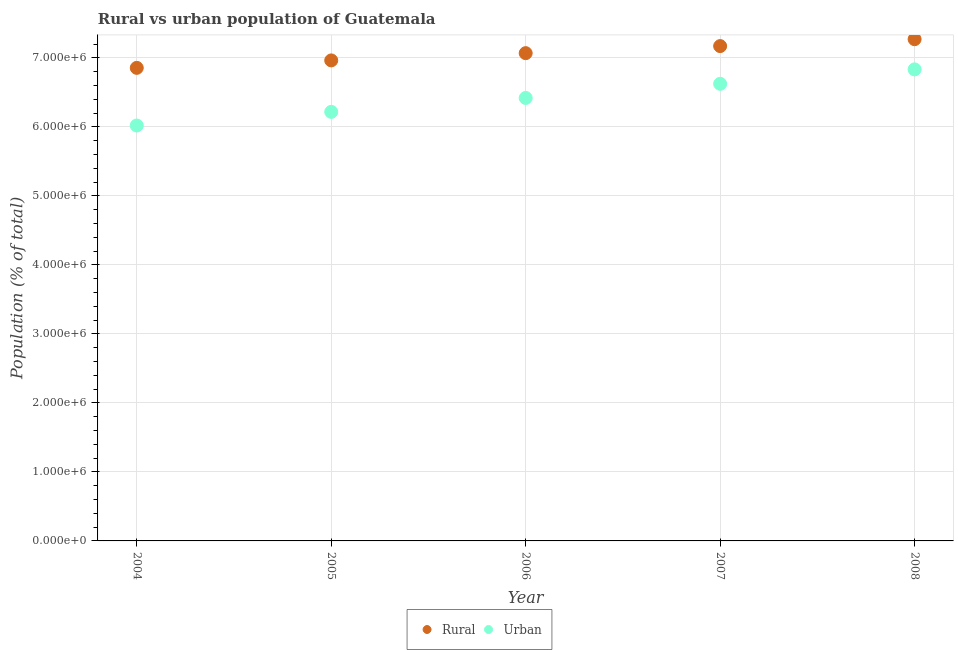How many different coloured dotlines are there?
Give a very brief answer. 2. What is the rural population density in 2005?
Make the answer very short. 6.96e+06. Across all years, what is the maximum urban population density?
Give a very brief answer. 6.83e+06. Across all years, what is the minimum rural population density?
Provide a succinct answer. 6.86e+06. What is the total urban population density in the graph?
Make the answer very short. 3.21e+07. What is the difference between the urban population density in 2005 and that in 2007?
Keep it short and to the point. -4.07e+05. What is the difference between the urban population density in 2006 and the rural population density in 2004?
Ensure brevity in your answer.  -4.36e+05. What is the average urban population density per year?
Give a very brief answer. 6.42e+06. In the year 2006, what is the difference between the rural population density and urban population density?
Your response must be concise. 6.49e+05. In how many years, is the urban population density greater than 1600000 %?
Your answer should be very brief. 5. What is the ratio of the rural population density in 2006 to that in 2007?
Ensure brevity in your answer.  0.99. Is the difference between the rural population density in 2005 and 2007 greater than the difference between the urban population density in 2005 and 2007?
Give a very brief answer. Yes. What is the difference between the highest and the second highest urban population density?
Ensure brevity in your answer.  2.09e+05. What is the difference between the highest and the lowest urban population density?
Your response must be concise. 8.13e+05. Is the urban population density strictly greater than the rural population density over the years?
Ensure brevity in your answer.  No. How many dotlines are there?
Your answer should be compact. 2. Are the values on the major ticks of Y-axis written in scientific E-notation?
Ensure brevity in your answer.  Yes. Does the graph contain any zero values?
Give a very brief answer. No. Does the graph contain grids?
Your response must be concise. Yes. How are the legend labels stacked?
Provide a short and direct response. Horizontal. What is the title of the graph?
Keep it short and to the point. Rural vs urban population of Guatemala. Does "DAC donors" appear as one of the legend labels in the graph?
Your answer should be compact. No. What is the label or title of the X-axis?
Provide a succinct answer. Year. What is the label or title of the Y-axis?
Offer a very short reply. Population (% of total). What is the Population (% of total) in Rural in 2004?
Make the answer very short. 6.86e+06. What is the Population (% of total) in Urban in 2004?
Provide a succinct answer. 6.02e+06. What is the Population (% of total) of Rural in 2005?
Give a very brief answer. 6.96e+06. What is the Population (% of total) of Urban in 2005?
Provide a short and direct response. 6.22e+06. What is the Population (% of total) of Rural in 2006?
Make the answer very short. 7.07e+06. What is the Population (% of total) of Urban in 2006?
Make the answer very short. 6.42e+06. What is the Population (% of total) in Rural in 2007?
Give a very brief answer. 7.17e+06. What is the Population (% of total) in Urban in 2007?
Offer a terse response. 6.63e+06. What is the Population (% of total) of Rural in 2008?
Your answer should be compact. 7.27e+06. What is the Population (% of total) in Urban in 2008?
Your response must be concise. 6.83e+06. Across all years, what is the maximum Population (% of total) in Rural?
Ensure brevity in your answer.  7.27e+06. Across all years, what is the maximum Population (% of total) in Urban?
Your response must be concise. 6.83e+06. Across all years, what is the minimum Population (% of total) of Rural?
Offer a terse response. 6.86e+06. Across all years, what is the minimum Population (% of total) in Urban?
Provide a short and direct response. 6.02e+06. What is the total Population (% of total) of Rural in the graph?
Keep it short and to the point. 3.53e+07. What is the total Population (% of total) of Urban in the graph?
Provide a succinct answer. 3.21e+07. What is the difference between the Population (% of total) in Rural in 2004 and that in 2005?
Offer a very short reply. -1.08e+05. What is the difference between the Population (% of total) of Urban in 2004 and that in 2005?
Your response must be concise. -1.98e+05. What is the difference between the Population (% of total) in Rural in 2004 and that in 2006?
Provide a succinct answer. -2.13e+05. What is the difference between the Population (% of total) in Urban in 2004 and that in 2006?
Keep it short and to the point. -3.99e+05. What is the difference between the Population (% of total) in Rural in 2004 and that in 2007?
Provide a succinct answer. -3.16e+05. What is the difference between the Population (% of total) of Urban in 2004 and that in 2007?
Ensure brevity in your answer.  -6.04e+05. What is the difference between the Population (% of total) in Rural in 2004 and that in 2008?
Keep it short and to the point. -4.16e+05. What is the difference between the Population (% of total) in Urban in 2004 and that in 2008?
Offer a terse response. -8.13e+05. What is the difference between the Population (% of total) of Rural in 2005 and that in 2006?
Your answer should be very brief. -1.05e+05. What is the difference between the Population (% of total) of Urban in 2005 and that in 2006?
Make the answer very short. -2.01e+05. What is the difference between the Population (% of total) in Rural in 2005 and that in 2007?
Ensure brevity in your answer.  -2.08e+05. What is the difference between the Population (% of total) in Urban in 2005 and that in 2007?
Your response must be concise. -4.07e+05. What is the difference between the Population (% of total) in Rural in 2005 and that in 2008?
Provide a succinct answer. -3.08e+05. What is the difference between the Population (% of total) of Urban in 2005 and that in 2008?
Keep it short and to the point. -6.16e+05. What is the difference between the Population (% of total) in Rural in 2006 and that in 2007?
Provide a short and direct response. -1.02e+05. What is the difference between the Population (% of total) in Urban in 2006 and that in 2007?
Provide a short and direct response. -2.05e+05. What is the difference between the Population (% of total) in Rural in 2006 and that in 2008?
Offer a very short reply. -2.02e+05. What is the difference between the Population (% of total) in Urban in 2006 and that in 2008?
Make the answer very short. -4.14e+05. What is the difference between the Population (% of total) of Rural in 2007 and that in 2008?
Provide a succinct answer. -1.00e+05. What is the difference between the Population (% of total) in Urban in 2007 and that in 2008?
Your answer should be very brief. -2.09e+05. What is the difference between the Population (% of total) of Rural in 2004 and the Population (% of total) of Urban in 2005?
Your answer should be very brief. 6.38e+05. What is the difference between the Population (% of total) of Rural in 2004 and the Population (% of total) of Urban in 2006?
Ensure brevity in your answer.  4.36e+05. What is the difference between the Population (% of total) of Rural in 2004 and the Population (% of total) of Urban in 2007?
Offer a terse response. 2.31e+05. What is the difference between the Population (% of total) of Rural in 2004 and the Population (% of total) of Urban in 2008?
Offer a very short reply. 2.21e+04. What is the difference between the Population (% of total) in Rural in 2005 and the Population (% of total) in Urban in 2006?
Your answer should be compact. 5.44e+05. What is the difference between the Population (% of total) in Rural in 2005 and the Population (% of total) in Urban in 2007?
Offer a very short reply. 3.39e+05. What is the difference between the Population (% of total) in Rural in 2005 and the Population (% of total) in Urban in 2008?
Keep it short and to the point. 1.30e+05. What is the difference between the Population (% of total) of Rural in 2006 and the Population (% of total) of Urban in 2007?
Your answer should be very brief. 4.44e+05. What is the difference between the Population (% of total) of Rural in 2006 and the Population (% of total) of Urban in 2008?
Offer a very short reply. 2.35e+05. What is the difference between the Population (% of total) in Rural in 2007 and the Population (% of total) in Urban in 2008?
Your answer should be very brief. 3.38e+05. What is the average Population (% of total) in Rural per year?
Provide a succinct answer. 7.07e+06. What is the average Population (% of total) in Urban per year?
Provide a short and direct response. 6.42e+06. In the year 2004, what is the difference between the Population (% of total) of Rural and Population (% of total) of Urban?
Keep it short and to the point. 8.36e+05. In the year 2005, what is the difference between the Population (% of total) in Rural and Population (% of total) in Urban?
Provide a short and direct response. 7.46e+05. In the year 2006, what is the difference between the Population (% of total) in Rural and Population (% of total) in Urban?
Make the answer very short. 6.49e+05. In the year 2007, what is the difference between the Population (% of total) in Rural and Population (% of total) in Urban?
Offer a very short reply. 5.47e+05. In the year 2008, what is the difference between the Population (% of total) in Rural and Population (% of total) in Urban?
Your response must be concise. 4.38e+05. What is the ratio of the Population (% of total) of Rural in 2004 to that in 2005?
Offer a terse response. 0.98. What is the ratio of the Population (% of total) of Urban in 2004 to that in 2005?
Ensure brevity in your answer.  0.97. What is the ratio of the Population (% of total) of Rural in 2004 to that in 2006?
Your response must be concise. 0.97. What is the ratio of the Population (% of total) of Urban in 2004 to that in 2006?
Provide a succinct answer. 0.94. What is the ratio of the Population (% of total) in Rural in 2004 to that in 2007?
Provide a short and direct response. 0.96. What is the ratio of the Population (% of total) in Urban in 2004 to that in 2007?
Offer a terse response. 0.91. What is the ratio of the Population (% of total) of Rural in 2004 to that in 2008?
Ensure brevity in your answer.  0.94. What is the ratio of the Population (% of total) of Urban in 2004 to that in 2008?
Your answer should be very brief. 0.88. What is the ratio of the Population (% of total) of Rural in 2005 to that in 2006?
Make the answer very short. 0.99. What is the ratio of the Population (% of total) in Urban in 2005 to that in 2006?
Give a very brief answer. 0.97. What is the ratio of the Population (% of total) in Rural in 2005 to that in 2007?
Ensure brevity in your answer.  0.97. What is the ratio of the Population (% of total) of Urban in 2005 to that in 2007?
Your answer should be very brief. 0.94. What is the ratio of the Population (% of total) in Rural in 2005 to that in 2008?
Offer a terse response. 0.96. What is the ratio of the Population (% of total) in Urban in 2005 to that in 2008?
Offer a very short reply. 0.91. What is the ratio of the Population (% of total) of Rural in 2006 to that in 2007?
Provide a succinct answer. 0.99. What is the ratio of the Population (% of total) in Urban in 2006 to that in 2007?
Provide a short and direct response. 0.97. What is the ratio of the Population (% of total) in Rural in 2006 to that in 2008?
Your answer should be very brief. 0.97. What is the ratio of the Population (% of total) in Urban in 2006 to that in 2008?
Give a very brief answer. 0.94. What is the ratio of the Population (% of total) of Rural in 2007 to that in 2008?
Offer a terse response. 0.99. What is the ratio of the Population (% of total) of Urban in 2007 to that in 2008?
Offer a very short reply. 0.97. What is the difference between the highest and the second highest Population (% of total) in Rural?
Your answer should be compact. 1.00e+05. What is the difference between the highest and the second highest Population (% of total) of Urban?
Give a very brief answer. 2.09e+05. What is the difference between the highest and the lowest Population (% of total) of Rural?
Offer a very short reply. 4.16e+05. What is the difference between the highest and the lowest Population (% of total) of Urban?
Your answer should be compact. 8.13e+05. 